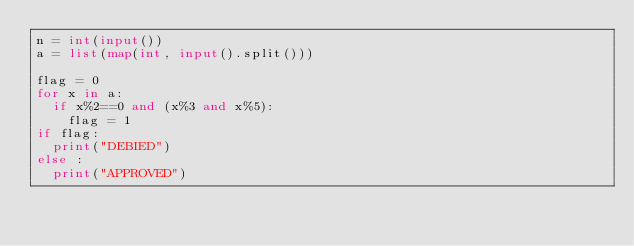Convert code to text. <code><loc_0><loc_0><loc_500><loc_500><_Python_>n = int(input())
a = list(map(int, input().split()))

flag = 0
for x in a:
  if x%2==0 and (x%3 and x%5):
    flag = 1
if flag:
  print("DEBIED")
else :
  print("APPROVED")
</code> 